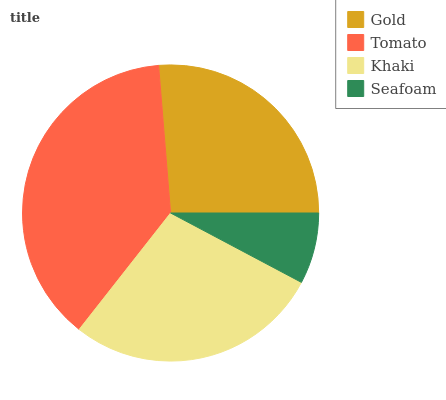Is Seafoam the minimum?
Answer yes or no. Yes. Is Tomato the maximum?
Answer yes or no. Yes. Is Khaki the minimum?
Answer yes or no. No. Is Khaki the maximum?
Answer yes or no. No. Is Tomato greater than Khaki?
Answer yes or no. Yes. Is Khaki less than Tomato?
Answer yes or no. Yes. Is Khaki greater than Tomato?
Answer yes or no. No. Is Tomato less than Khaki?
Answer yes or no. No. Is Khaki the high median?
Answer yes or no. Yes. Is Gold the low median?
Answer yes or no. Yes. Is Gold the high median?
Answer yes or no. No. Is Khaki the low median?
Answer yes or no. No. 